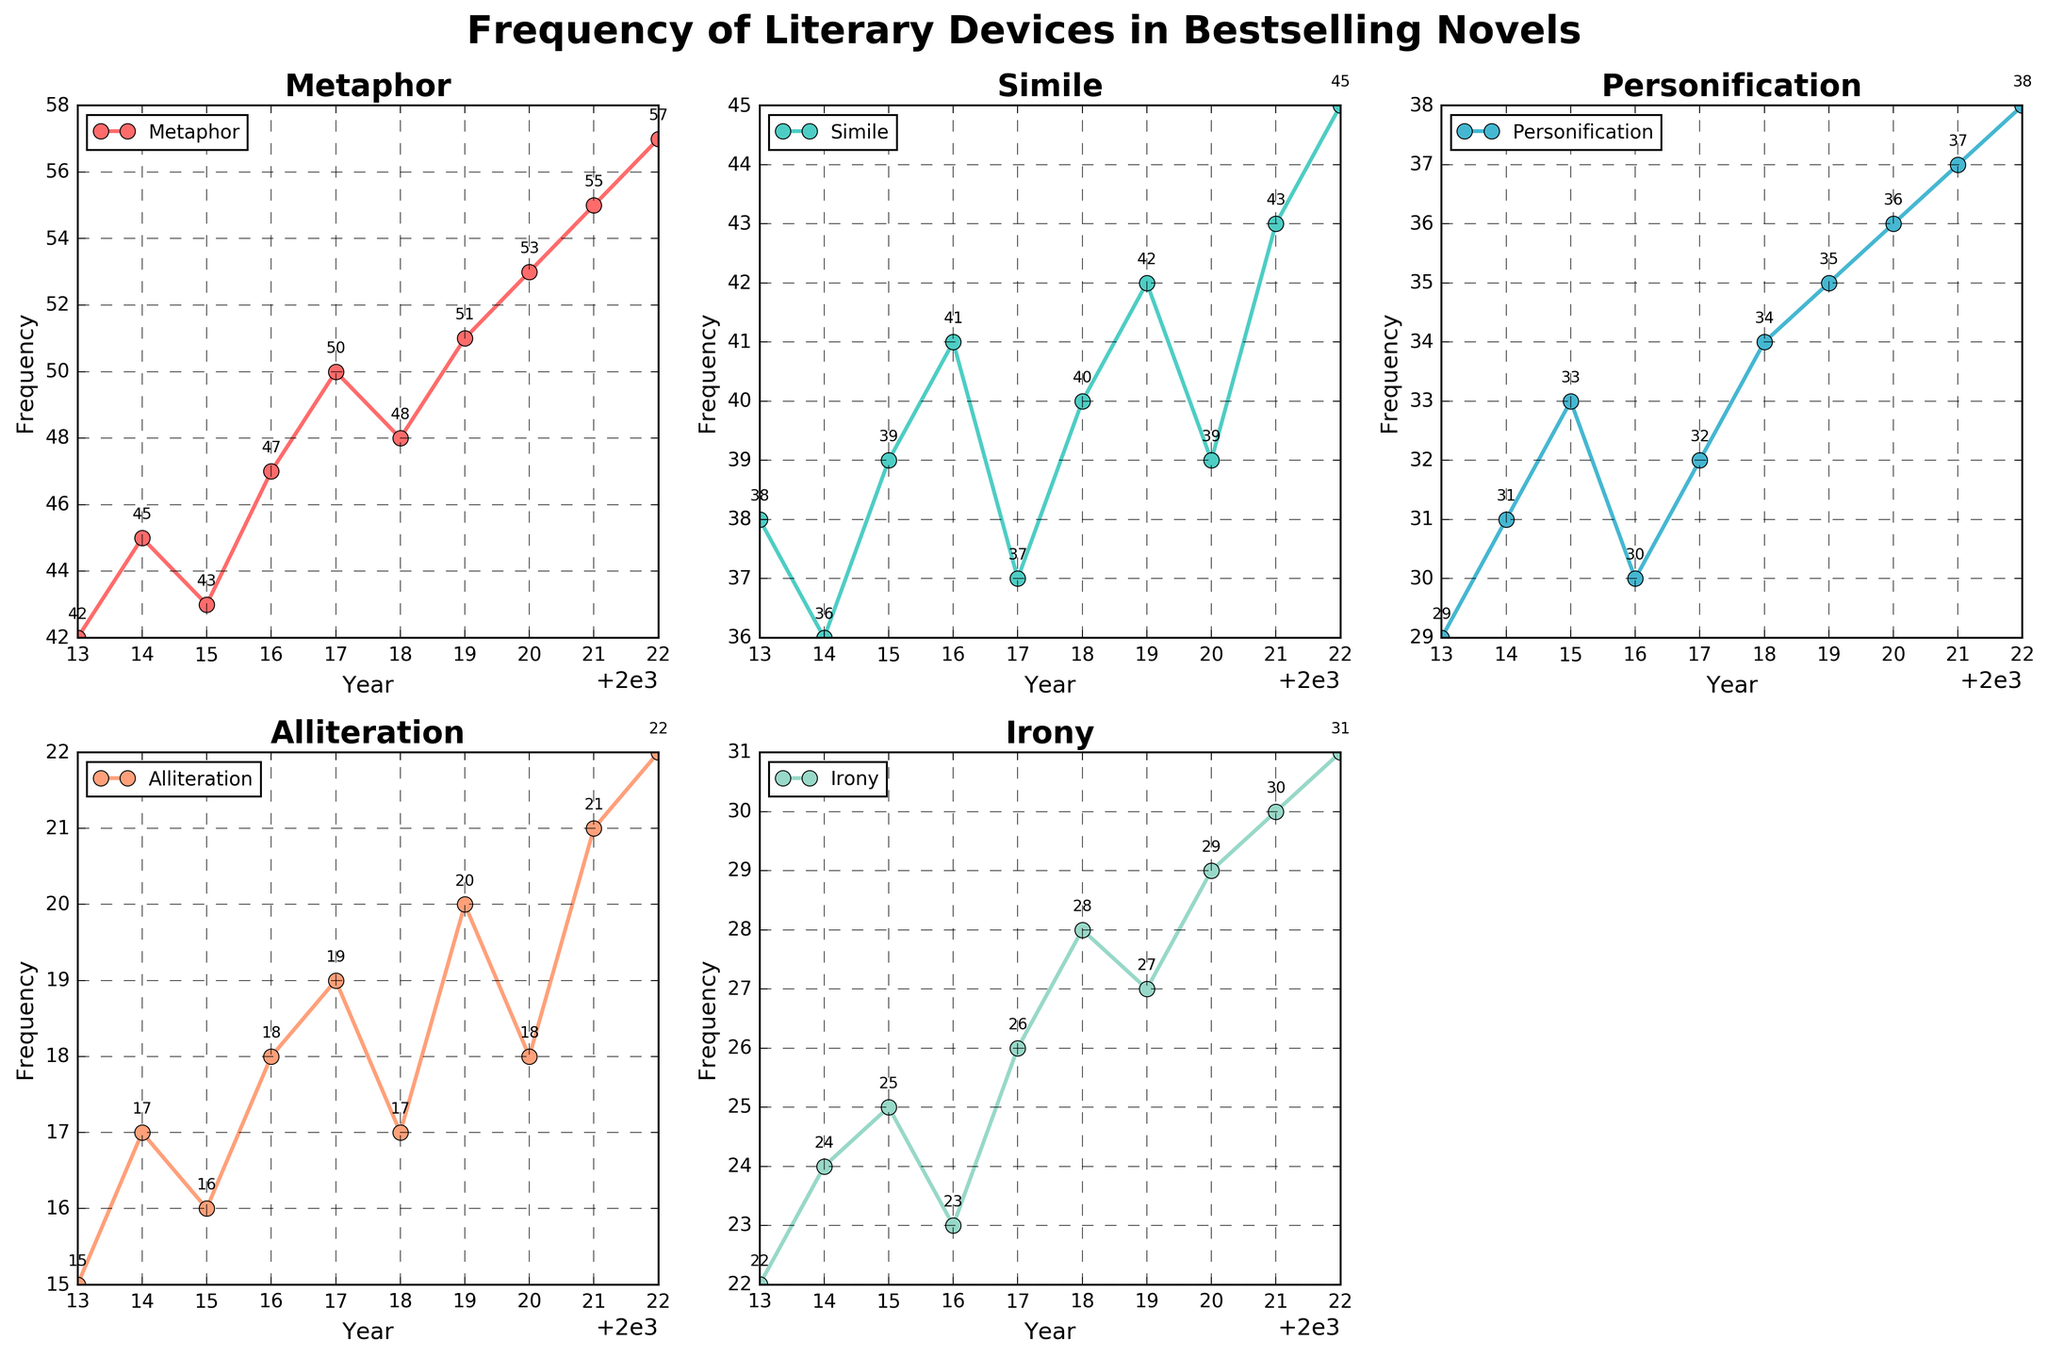What's the title of the figure? The figure's title is displayed at the top and is usually larger and bolder than other text elements. Here, it states, "Frequency of Literary Devices in Bestselling Novels".
Answer: Frequency of Literary Devices in Bestselling Novels What is the frequency of Metaphor in the year 2020? Locate the subplot for Metaphor and trace the point where the year 2020 intersects with the Metaphor line. The annotated value shows the frequency.
Answer: 53 Which literary device had the least frequency in 2013? Compare all the subplots for the frequency values corresponding to the year 2013. The device with the smallest number wins.
Answer: Alliteration How has the frequency of Irony changed from 2013 to 2022? Look at the subplot for Irony and find the frequency values for the years 2013 and 2022. Subtract the 2013 value from the 2022 value to find the change. _Irony (2022) = 31; Irony (2013) = 22; Change = 31 - 22 = 9._
Answer: Increased by 9 Which literary device shows the most consistent frequency trend over the years? Examine the plots of all literary devices to see which one has the least variation in its line plot. Personification and Alliteration show consistent trends with slight increments, but Personification's line is smoother and steadier.
Answer: Personification Which year showed the highest use of Simile? Find the maximum point on the Simile subplot and read the corresponding year. The highest point shows the highest frequency.
Answer: 2022 Compare the frequency growth patterns of Metaphor and Simile. Which one grew more rapidly? Examine the slopes of the lines in the Metaphor and Simile subplots from 2013 to 2022. Calculate the total increase for both: _Metaphor: 57-42=15_, _Simile: 45-38=7_. Metaphor had a greater increase over the years.
Answer: Metaphor What is the average frequency of Alliteration over the decade? Add up the Alliteration frequencies from 2013 to 2022 and divide by the number of years (10). _Sum = 15+17+16+18+19+17+20+18+21+22 = 183; Average = 183/10 = 18.3._
Answer: 18.3 In which year did Personification and Irony share the same frequency? Compare year by year values in the subplots of Personification and Irony to find any matching frequencies. _Both Personification and Irony have a frequency of 30 in 2016._
Answer: 2016 Which literary device experienced the biggest jump in frequency from one year to the next? Compare year-on-year changes for each literary device across all subplots. The biggest jump can be noticed in Irony between 2017 and 2018 _from 26 to 28_, and between 2020 and 2021 _from 29 to 30_, and other jumps, but Simile had notable jump from 39 to 43 between 2020 and 2021.
Answer: Simile 